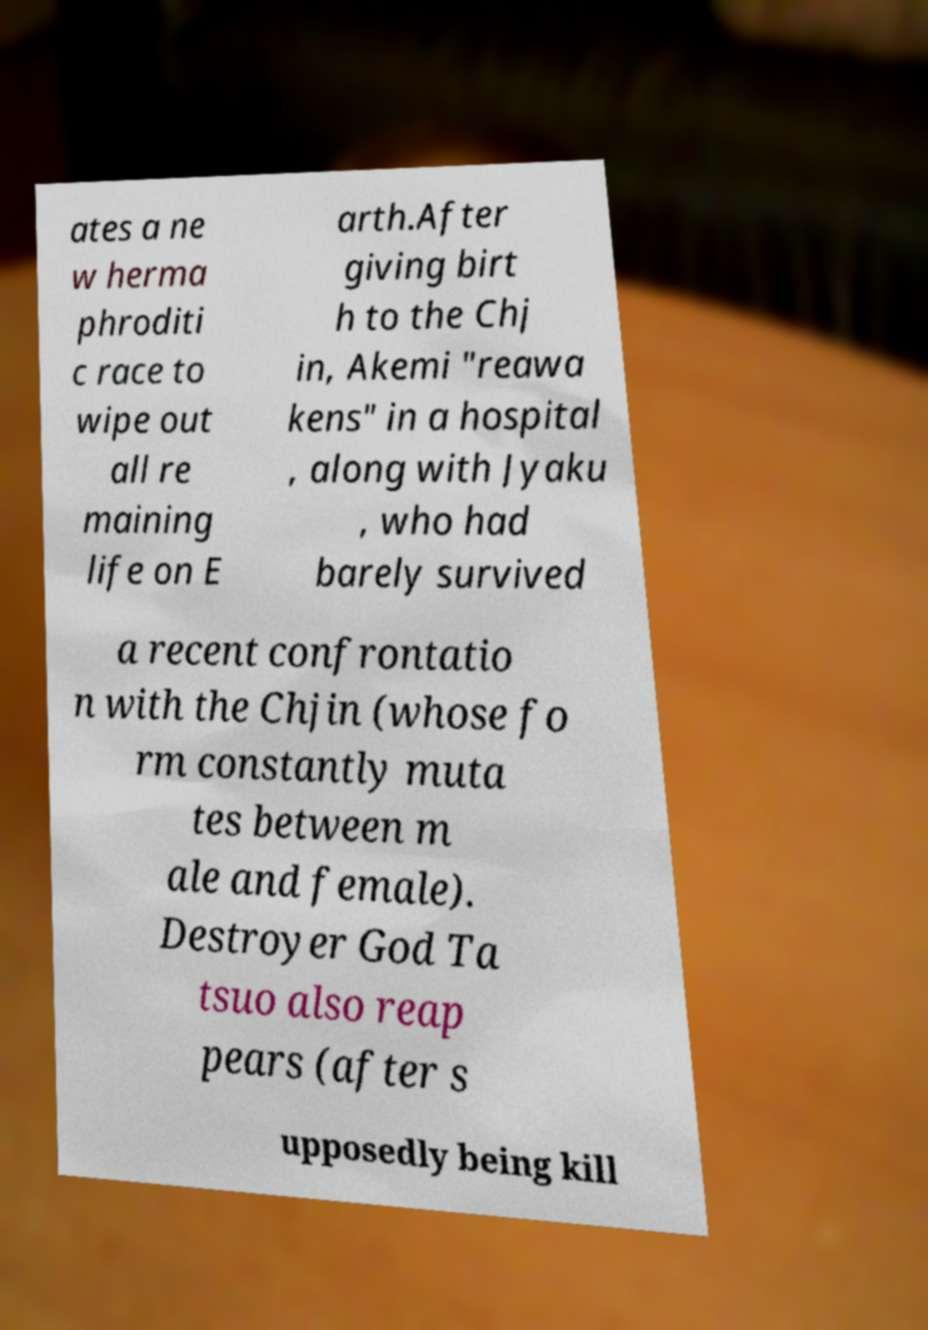Please identify and transcribe the text found in this image. ates a ne w herma phroditi c race to wipe out all re maining life on E arth.After giving birt h to the Chj in, Akemi "reawa kens" in a hospital , along with Jyaku , who had barely survived a recent confrontatio n with the Chjin (whose fo rm constantly muta tes between m ale and female). Destroyer God Ta tsuo also reap pears (after s upposedly being kill 